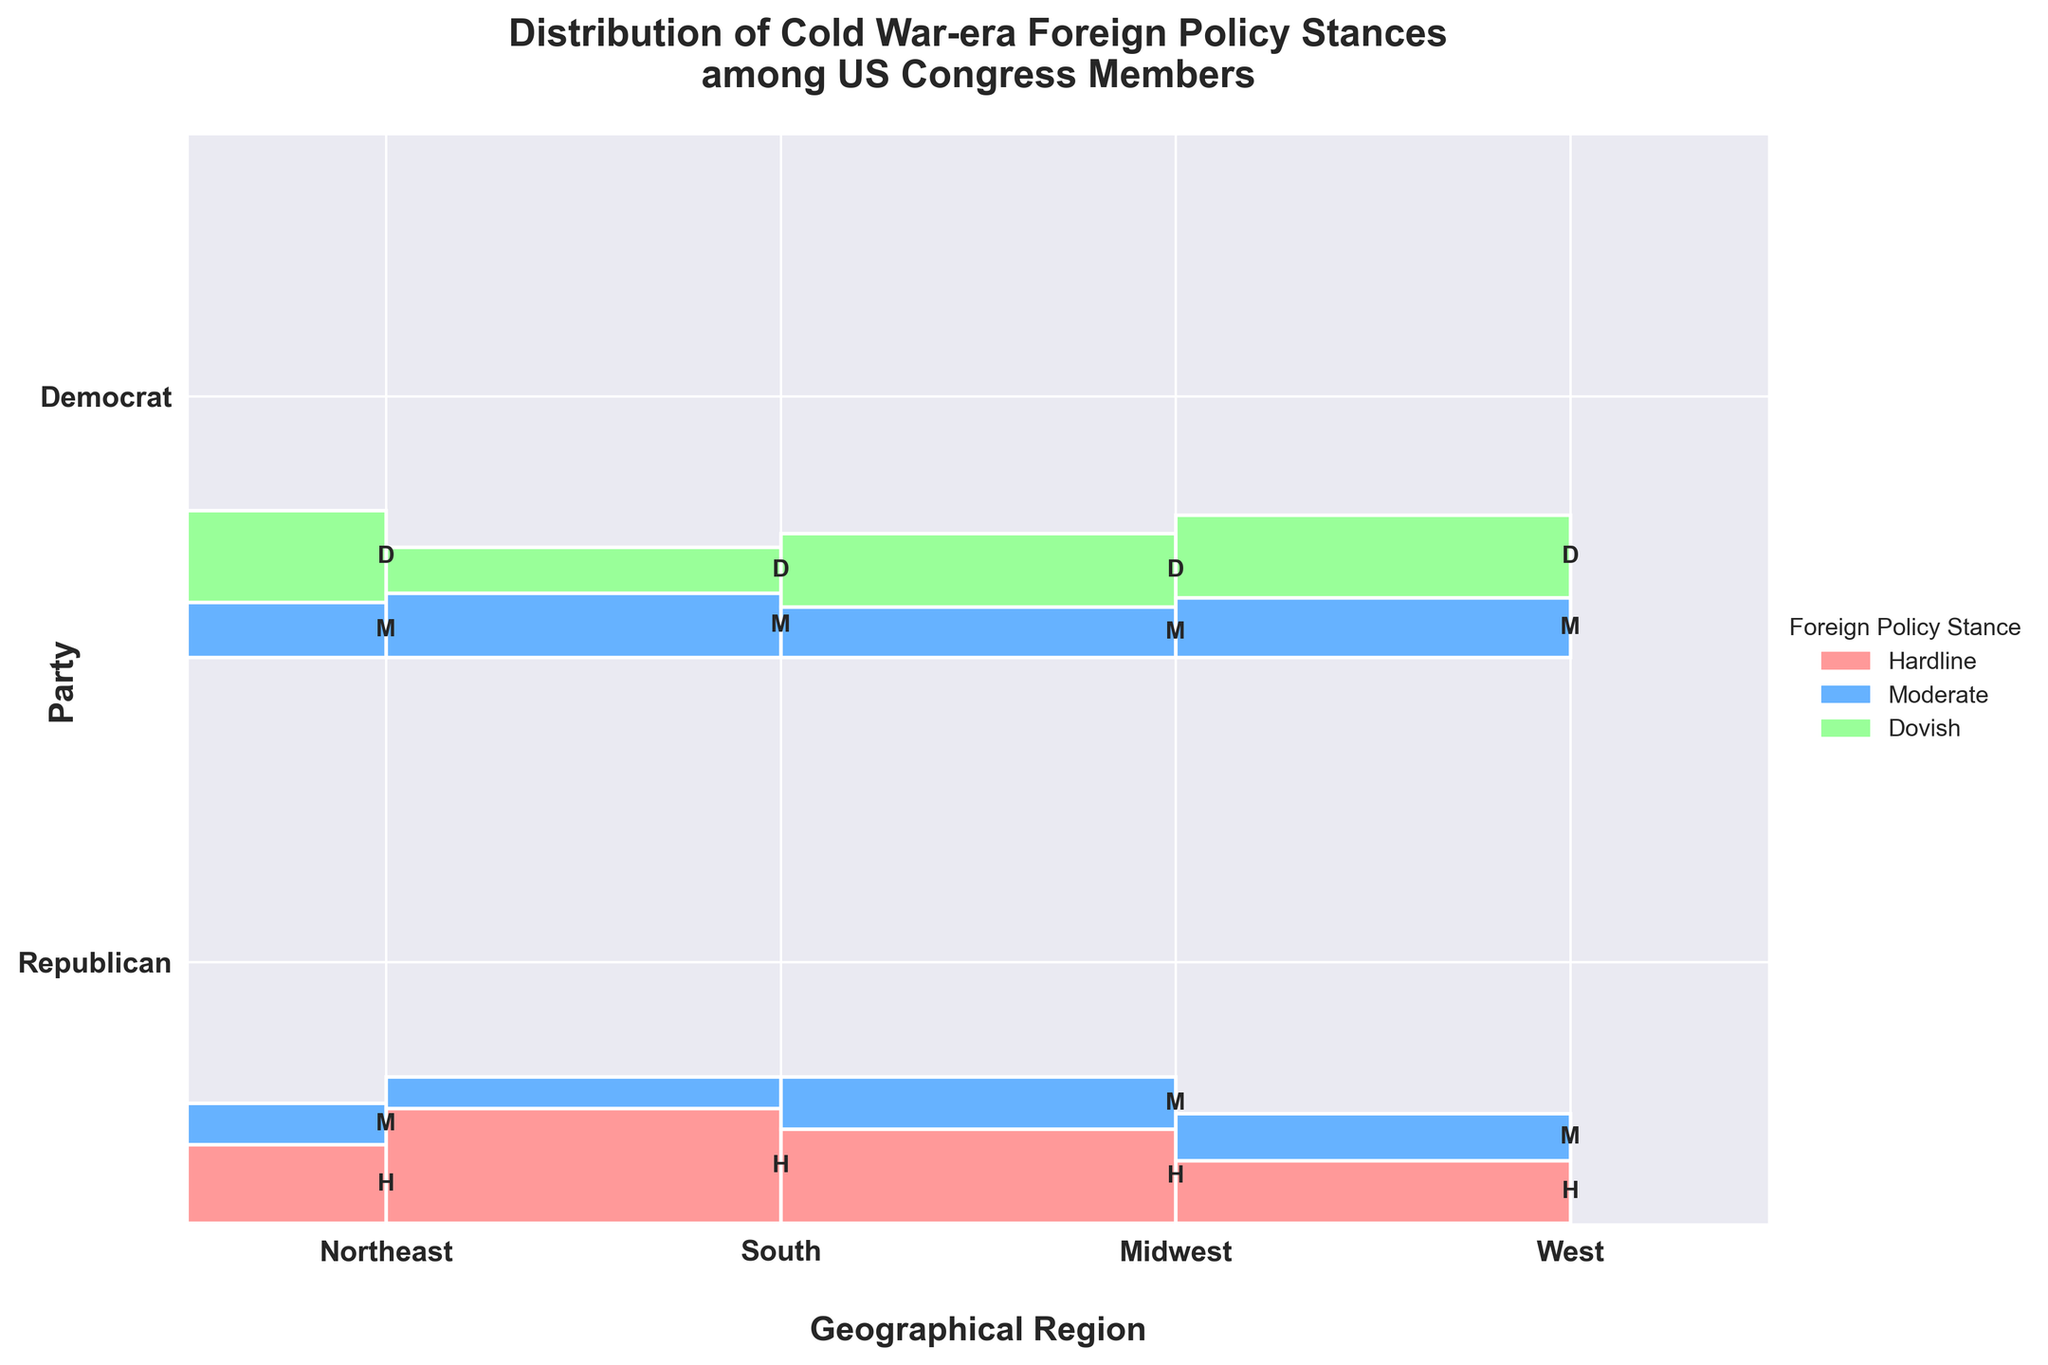What's the title of the figure? The title is displayed at the top of the figure and should be read directly.
Answer: Distribution of Cold War-era Foreign Policy Stances among US Congress Members What are the four geographical regions shown on the x-axis? The x-axis shows the geographical regions, labeled directly under the bars.
Answer: Northeast, South, Midwest, West Which party has a higher proportion of Hardline stances in the Midwest region? Look at the Midwest region for both Republican and Democrat parties and compare the heights of the Hardline sections. The taller section indicates a higher proportion.
Answer: Republican Which geographical region has the highest number of Dovish Democrats? Compare the height of the Dovish section across the Northeast, South, Midwest, and West regions for Democrats. The tallest section indicates the highest number.
Answer: Northeast How many foreign policy stances are categorized in the figure? The legend at the side of the figure lists the categories: Hardline, Moderate, and Dovish. Count these categories.
Answer: 3 In the South region, which stance is more prevalent among Republicans, Hardline or Moderate? Compare the heights of the Hardline and Moderate sections for Republicans in the South region. The taller section indicates the more prevalent stance.
Answer: Hardline Between the Northeast and the West regions, which one shows a higher proportion of Moderate Democrats? Compare the heights of the Moderate sections for Democrats between the Northeast and the West regions. The taller section indicates a higher proportion.
Answer: West Which party has a more diverse set of foreign policy stances in the Northeast region? Look at both parties in the Northeast region and see which one has bars representing more than one foreign policy stance (i.e., more colors).
Answer: Democrat Is the Hardline stance more commonly associated with Republicans or Democrats? Compare the Hardline sections across all regions for both parties. Higher sections for one party indicate more common association.
Answer: Republicans What is the proportion of Moderate stance among Republicans in the West region compared to the total Republican stances in the West region? Calculate the proportion of Moderate views by dividing the height of the Moderate section by the total height of all sections for Republicans in the West region.
Answer: 9 out of 21 